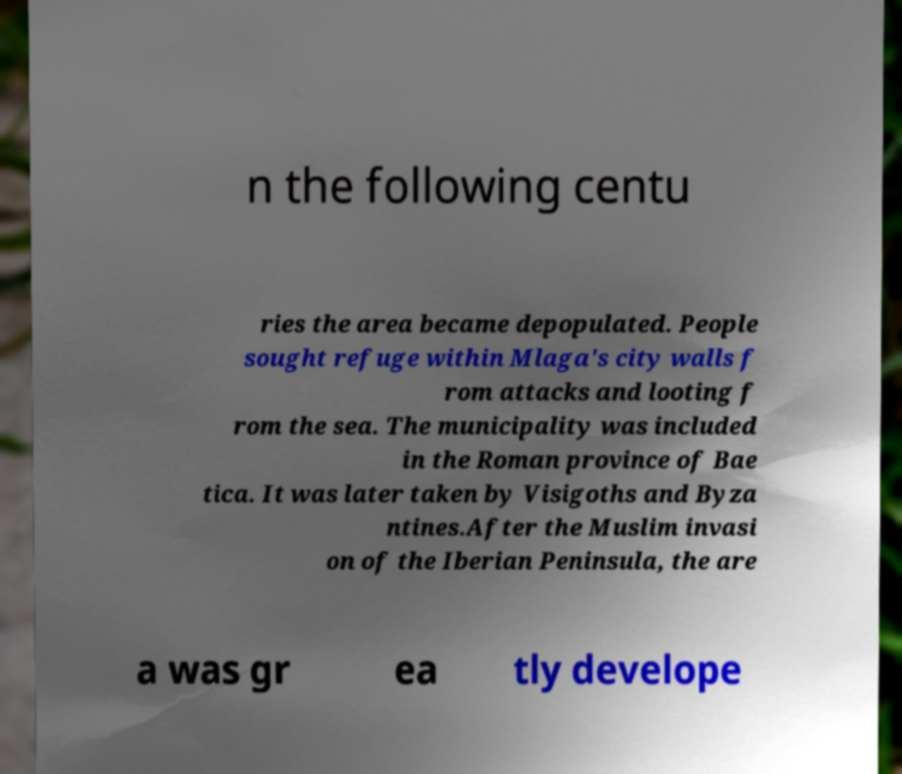There's text embedded in this image that I need extracted. Can you transcribe it verbatim? n the following centu ries the area became depopulated. People sought refuge within Mlaga's city walls f rom attacks and looting f rom the sea. The municipality was included in the Roman province of Bae tica. It was later taken by Visigoths and Byza ntines.After the Muslim invasi on of the Iberian Peninsula, the are a was gr ea tly develope 